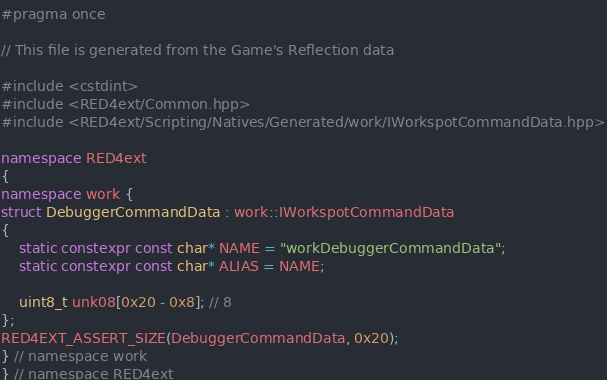Convert code to text. <code><loc_0><loc_0><loc_500><loc_500><_C++_>#pragma once

// This file is generated from the Game's Reflection data

#include <cstdint>
#include <RED4ext/Common.hpp>
#include <RED4ext/Scripting/Natives/Generated/work/IWorkspotCommandData.hpp>

namespace RED4ext
{
namespace work { 
struct DebuggerCommandData : work::IWorkspotCommandData
{
    static constexpr const char* NAME = "workDebuggerCommandData";
    static constexpr const char* ALIAS = NAME;

    uint8_t unk08[0x20 - 0x8]; // 8
};
RED4EXT_ASSERT_SIZE(DebuggerCommandData, 0x20);
} // namespace work
} // namespace RED4ext
</code> 